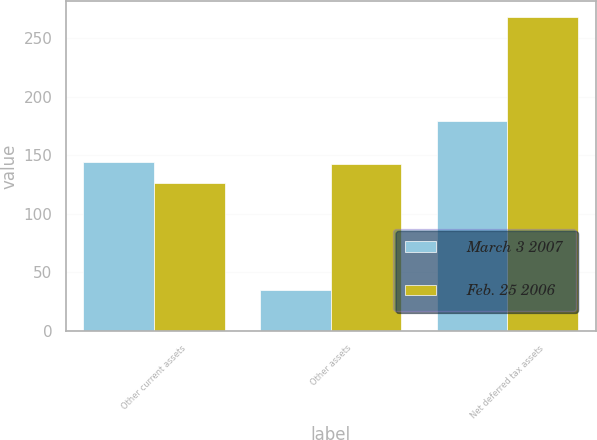Convert chart to OTSL. <chart><loc_0><loc_0><loc_500><loc_500><stacked_bar_chart><ecel><fcel>Other current assets<fcel>Other assets<fcel>Net deferred tax assets<nl><fcel>March 3 2007<fcel>144<fcel>35<fcel>179<nl><fcel>Feb. 25 2006<fcel>126<fcel>142<fcel>268<nl></chart> 